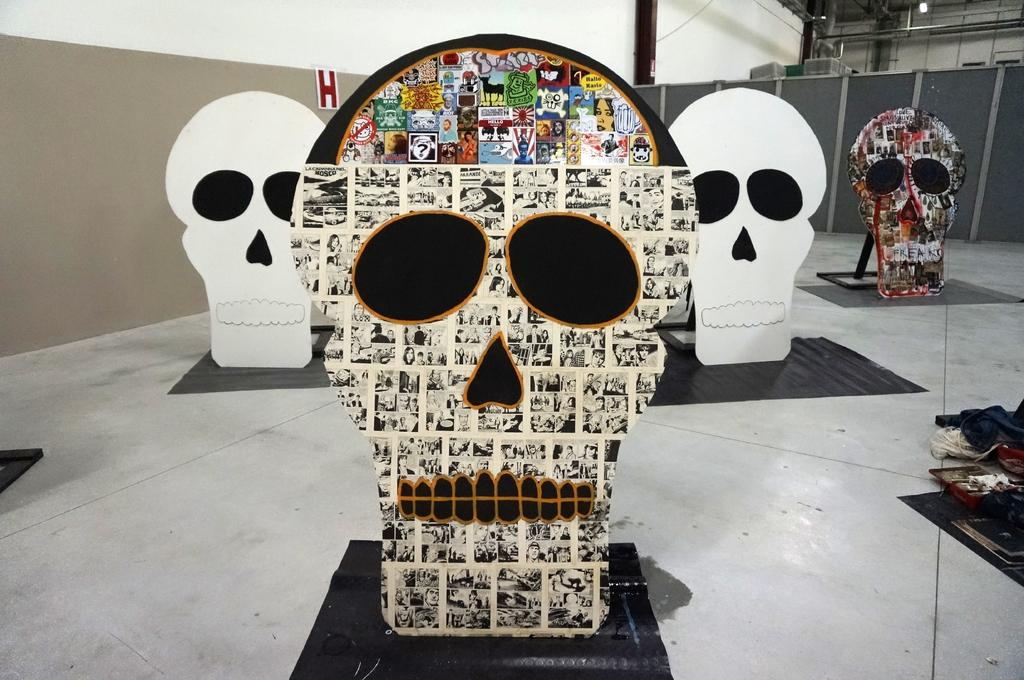What type of posters are featured in the image? There are skull posters in the image. What can be seen beneath the posters? There is a floor visible in the image. What is located behind the posters? There is a wall in the background of the image. What type of birthday celebration is taking place in the image? There is no indication of a birthday celebration in the image, as it only features skull posters, a floor, and a wall in the background. 